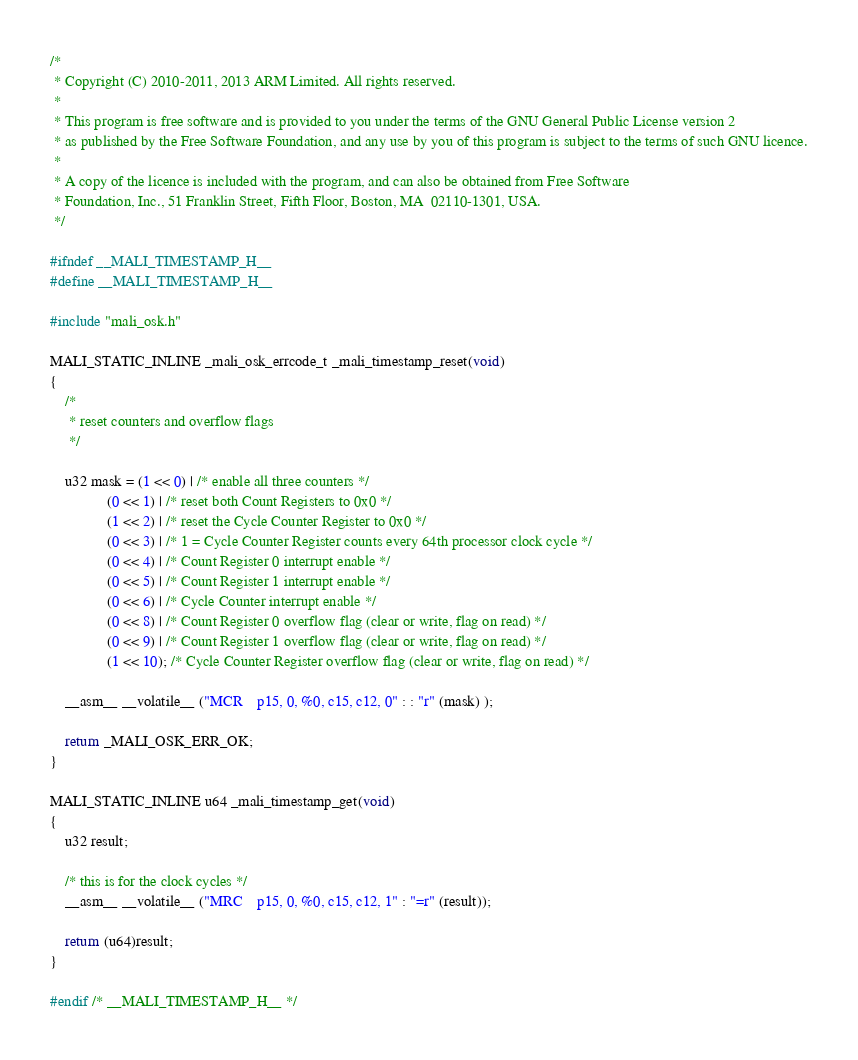Convert code to text. <code><loc_0><loc_0><loc_500><loc_500><_C_>/*
 * Copyright (C) 2010-2011, 2013 ARM Limited. All rights reserved.
 * 
 * This program is free software and is provided to you under the terms of the GNU General Public License version 2
 * as published by the Free Software Foundation, and any use by you of this program is subject to the terms of such GNU licence.
 * 
 * A copy of the licence is included with the program, and can also be obtained from Free Software
 * Foundation, Inc., 51 Franklin Street, Fifth Floor, Boston, MA  02110-1301, USA.
 */

#ifndef __MALI_TIMESTAMP_H__
#define __MALI_TIMESTAMP_H__

#include "mali_osk.h"

MALI_STATIC_INLINE _mali_osk_errcode_t _mali_timestamp_reset(void)
{
	/*
	 * reset counters and overflow flags
	 */

    u32 mask = (1 << 0) | /* enable all three counters */
	           (0 << 1) | /* reset both Count Registers to 0x0 */
	           (1 << 2) | /* reset the Cycle Counter Register to 0x0 */
	           (0 << 3) | /* 1 = Cycle Counter Register counts every 64th processor clock cycle */
	           (0 << 4) | /* Count Register 0 interrupt enable */
	           (0 << 5) | /* Count Register 1 interrupt enable */
	           (0 << 6) | /* Cycle Counter interrupt enable */
	           (0 << 8) | /* Count Register 0 overflow flag (clear or write, flag on read) */
	           (0 << 9) | /* Count Register 1 overflow flag (clear or write, flag on read) */
	           (1 << 10); /* Cycle Counter Register overflow flag (clear or write, flag on read) */

	__asm__ __volatile__ ("MCR    p15, 0, %0, c15, c12, 0" : : "r" (mask) );

	return _MALI_OSK_ERR_OK;
}

MALI_STATIC_INLINE u64 _mali_timestamp_get(void)
{
	u32 result;

	/* this is for the clock cycles */
	__asm__ __volatile__ ("MRC    p15, 0, %0, c15, c12, 1" : "=r" (result));

	return (u64)result;
}

#endif /* __MALI_TIMESTAMP_H__ */
</code> 